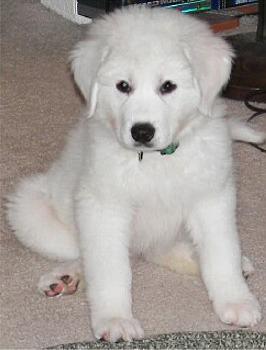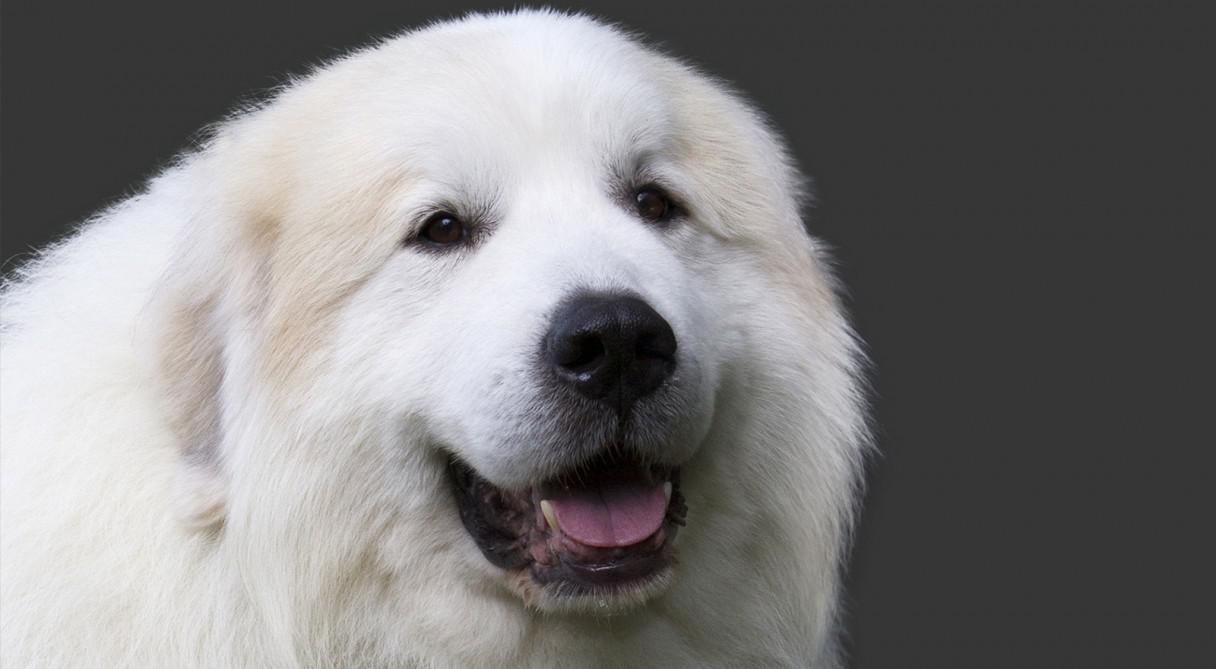The first image is the image on the left, the second image is the image on the right. Given the left and right images, does the statement "One dog has its mouth open." hold true? Answer yes or no. Yes. The first image is the image on the left, the second image is the image on the right. Given the left and right images, does the statement "Each image contains no more than one white dog, the dog in the right image is outdoors, and at least one dog wears a collar." hold true? Answer yes or no. No. 